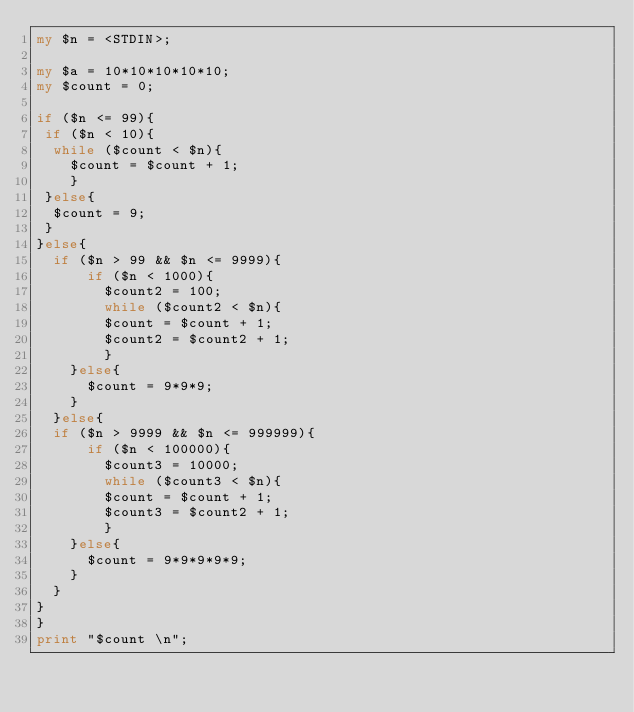Convert code to text. <code><loc_0><loc_0><loc_500><loc_500><_Perl_>my $n = <STDIN>;

my $a = 10*10*10*10*10;
my $count = 0;

if ($n <= 99){
 if ($n < 10){
	while ($count < $n){
 		$count = $count + 1;
    }
 }else{
 	$count = 9;
 }
}else{
	if ($n > 99 && $n <= 9999){
    	if ($n < 1000){
    		$count2 = 100;
	    	while ($count2 < $n){
 				$count = $count + 1;
 				$count2 = $count2 + 1;
   			}
		}else{
 			$count = 9*9*9;
 		}
	}else{
	if ($n > 9999 && $n <= 999999){
    	if ($n < 100000){
    		$count3 = 10000;
	    	while ($count3 < $n){
 				$count = $count + 1;
 				$count3 = $count2 + 1;
   			}
		}else{
 			$count = 9*9*9*9*9;
 		}
	}
}
}
print "$count \n";</code> 